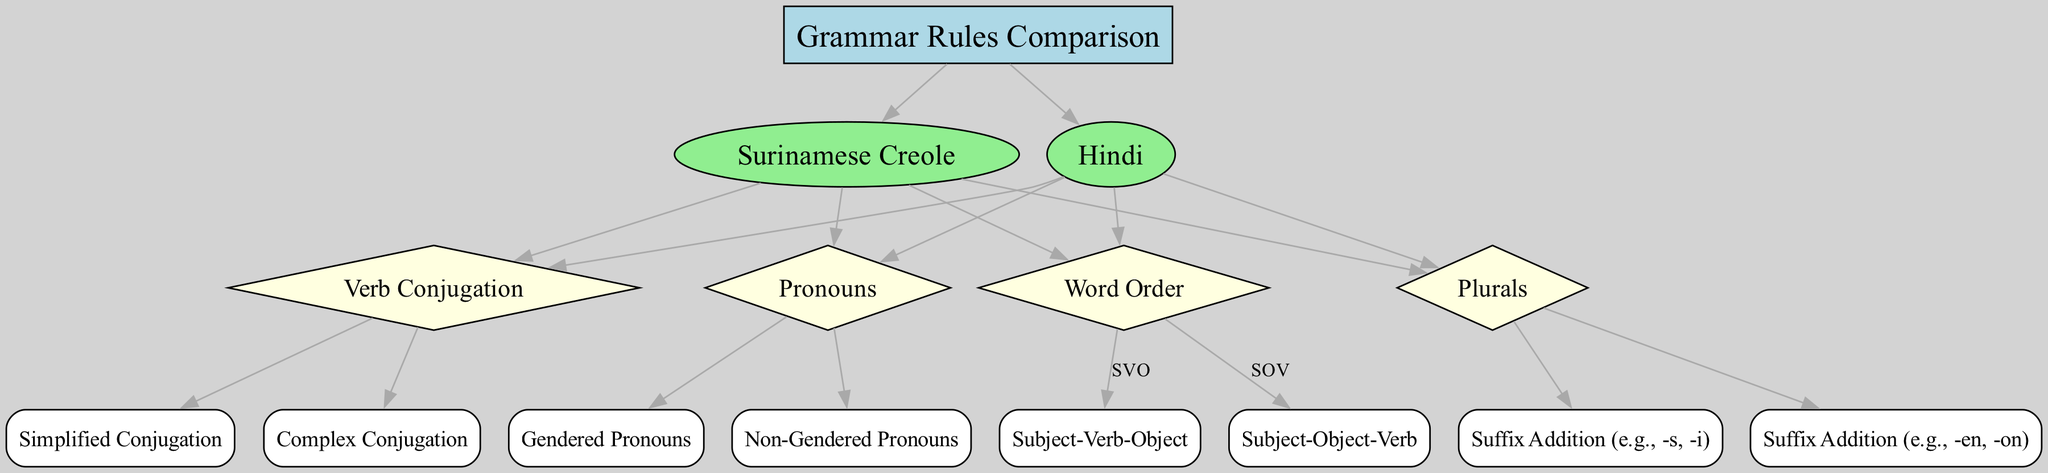What is the primary subject of the diagram? The diagram focuses on comparing grammar rules between Surinamese Creole and Hindi, as indicated in the central node labeled "Grammar Rules Comparison."
Answer: Grammar Rules Comparison How many nodes are present in the diagram? Counting the nodes listed in the provided data, there are 15 distinct nodes represented in the diagram.
Answer: 15 What type of word order does Surinamese Creole primarily use? The diagram indicates that Surinamese Creole utilizes a Subject-Verb-Object (SVO) structure, as shown under the "Word Order" node leading to SVO.
Answer: Subject-Verb-Object What kind of pronouns does Hindi utilize according to the diagram? The diagram specifies that Hindi uses gendered pronouns, as it flows from the "Pronouns" node to the "Gendered Pronouns" node.
Answer: Gendered Pronouns Which language has simplified verb conjugation? The diagram indicates that Surinamese Creole has simplified conjugation under the "Verb Conjugation" node, which refers to "Simplified Conjugation."
Answer: Simplified Conjugation How are plurals formed in Surinamese Creole? The diagram shows that plurals in Surinamese Creole are formed by suffix addition, specifically using examples like -s or -i, linking from the "Plurals" node to the suffix addition.
Answer: Suffix Addition (e.g., -s, -i) Which nodes are connected to the "Word Order" node? The "Word Order" node is connected to two nodes: "Subject-Verb-Object" and "Subject-Object-Verb," indicating the two different structures visualized in the diagram.
Answer: Subject-Verb-Object, Subject-Object-Verb What are the conjugation complexities in Hindi? The diagram shows that Hindi has complex conjugation as one of its features under the "Verb Conjugation" category, leading to the "Complex Conjugation" node.
Answer: Complex Conjugation 